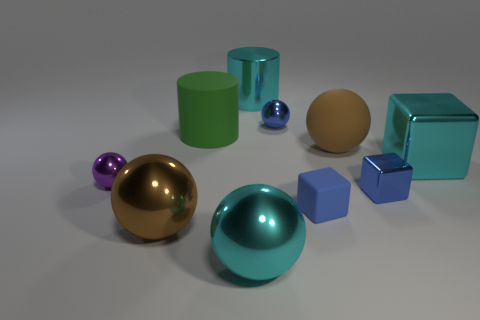The big object that is left of the cyan metal sphere and behind the blue shiny cube is made of what material? Based on the image, the large object to the left of the cyan metal sphere and behind the bluish cube appears to have a matte texture that is not reflective, suggesting that it could be made of a solid material such as plastic or ceramic rather than rubber. 